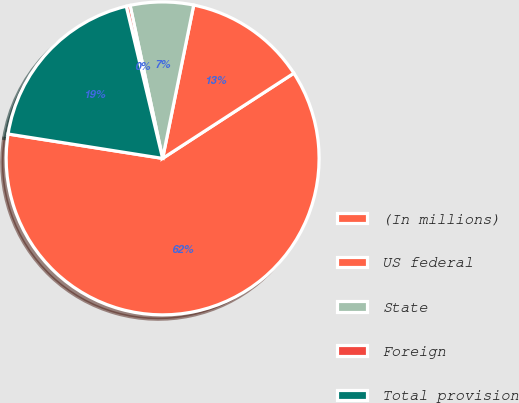Convert chart. <chart><loc_0><loc_0><loc_500><loc_500><pie_chart><fcel>(In millions)<fcel>US federal<fcel>State<fcel>Foreign<fcel>Total provision<nl><fcel>61.65%<fcel>12.65%<fcel>6.52%<fcel>0.4%<fcel>18.77%<nl></chart> 